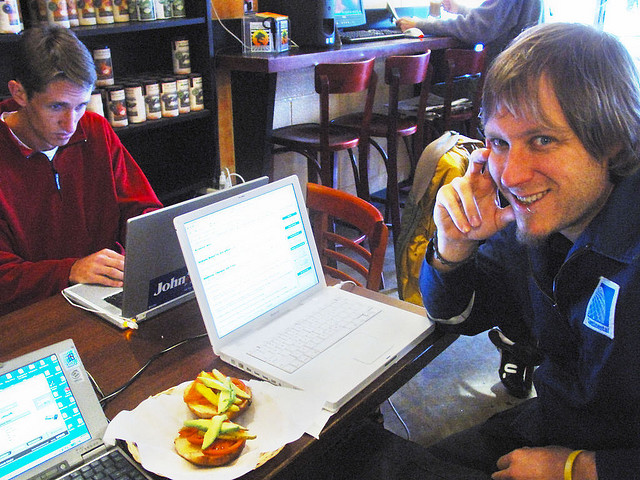How would you describe the atmosphere of the place where these individuals are? The atmosphere looks to be casual and relaxed, possibly a café or coffee shop. The people present appear to be engaged in their laptops, suggesting that the place provides a comfortable environment for work or study with access to Wi-Fi. There is visible lighting and the presence of other patrons in the background enjoying their time.  Can you tell me what the person in the forefront is doing? The person in the foreground is smiling and posing for the photograph, while also holding what seems to be a sandwich. It appears they are taking a break from their activity to engage with the photographer, showing a moment of leisure amidst their work or study routine. 